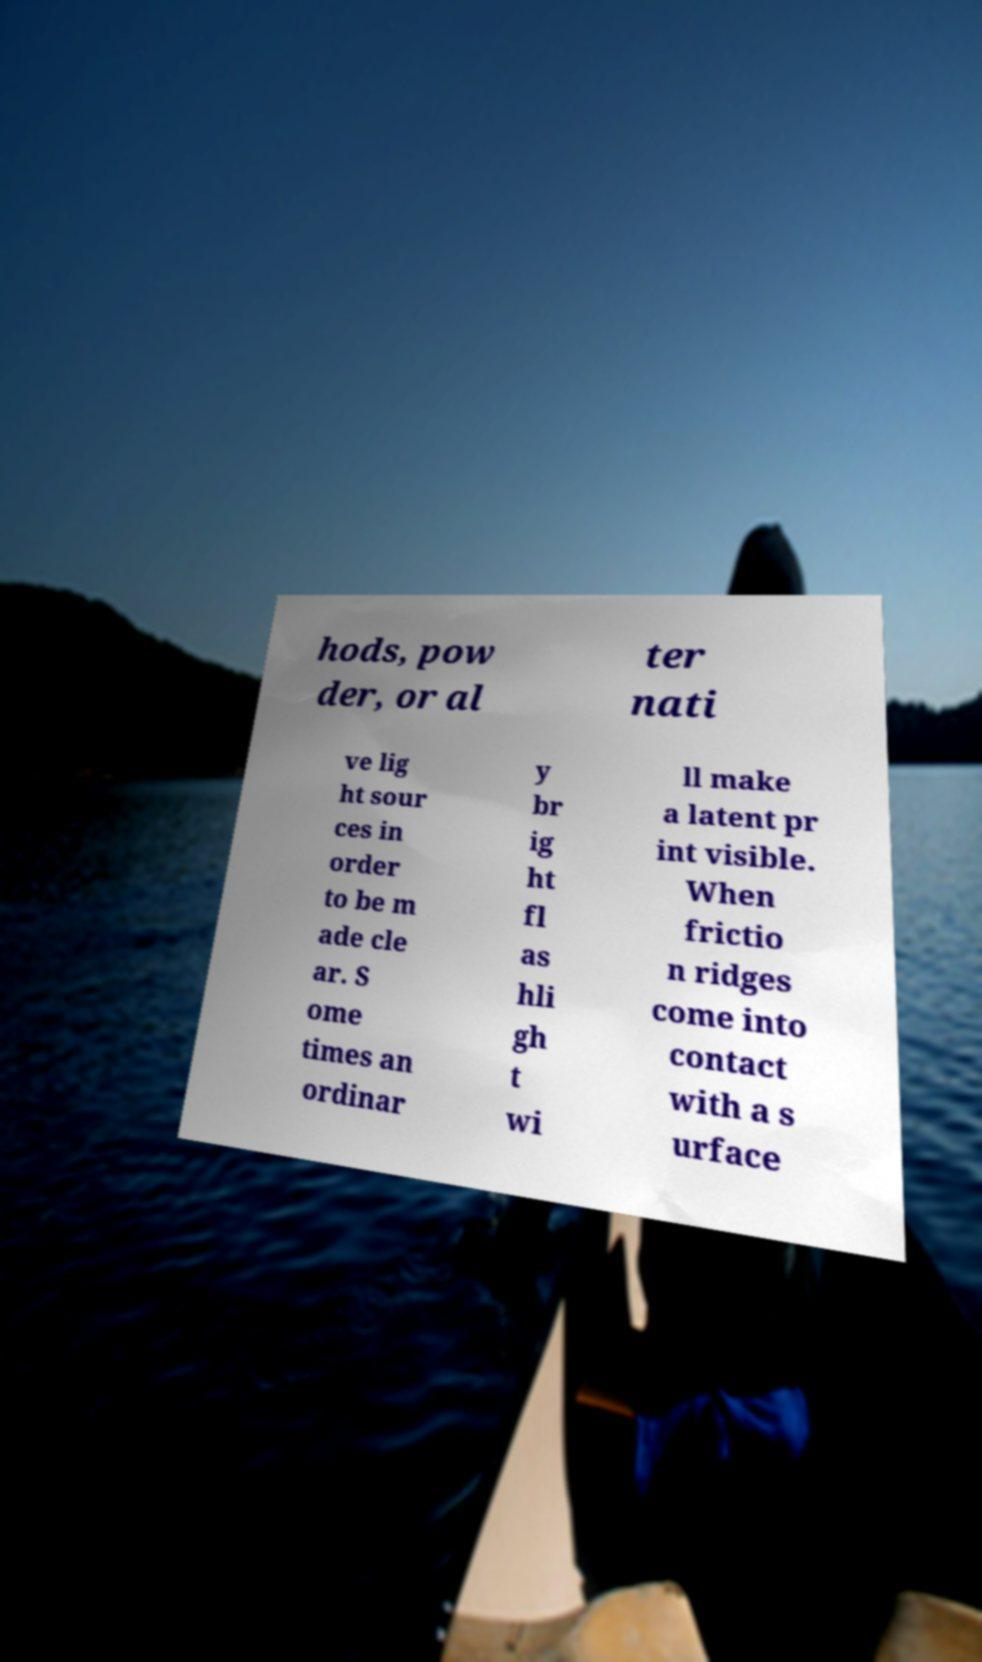What messages or text are displayed in this image? I need them in a readable, typed format. hods, pow der, or al ter nati ve lig ht sour ces in order to be m ade cle ar. S ome times an ordinar y br ig ht fl as hli gh t wi ll make a latent pr int visible. When frictio n ridges come into contact with a s urface 